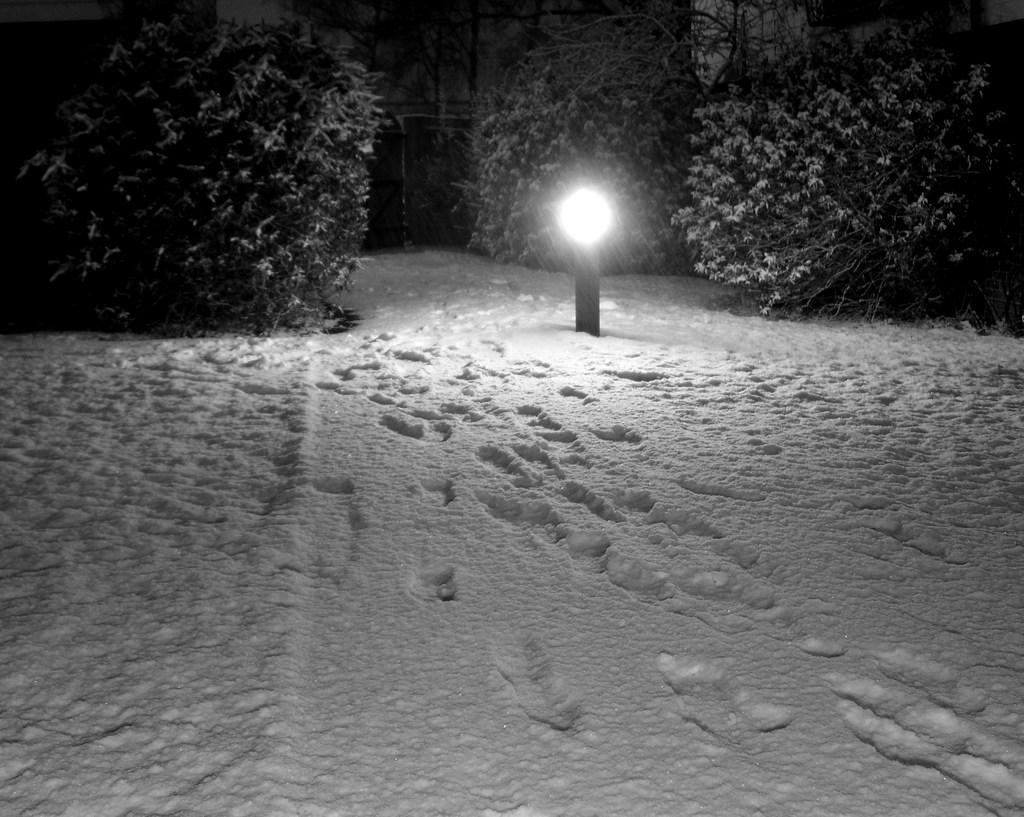What can be seen on the snow in the image? There are footprints on the snow in the image. What is located in the middle of the image? There is a light in the middle of the image. Where are plants visible in the image? There are plants in the top left and top right of the image. How many pieces of coal can be seen in the image? There is no coal present in the image. What type of rabbit is hopping through the plants in the image? There are no rabbits present in the image. 